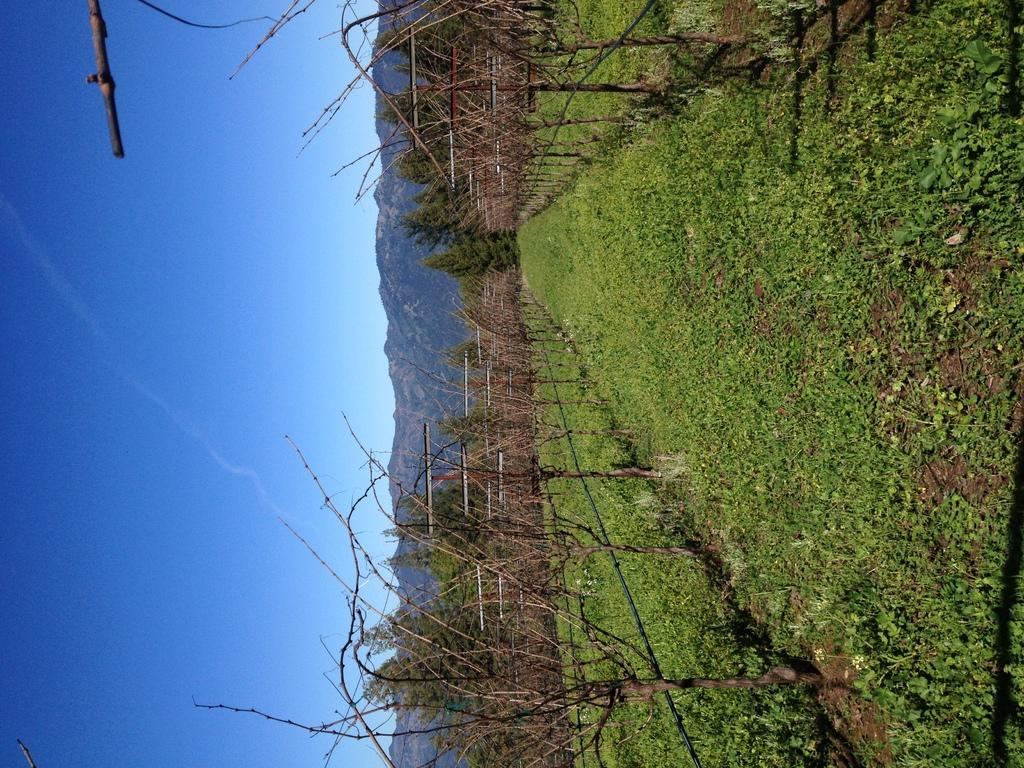What is located in the center of the image? There are trees, poles, and fences in the center of the image. What type of natural feature can be seen in the background of the image? There are hills visible in the background of the image. What is at the bottom of the image? There is ground at the bottom of the image. What is visible at the top of the image? The sky is visible at the top of the image. What is the distribution of the trees in the image compared to the poles? There is no comparison made between the distribution of trees and poles in the image, as the question is not relevant to the information provided. 